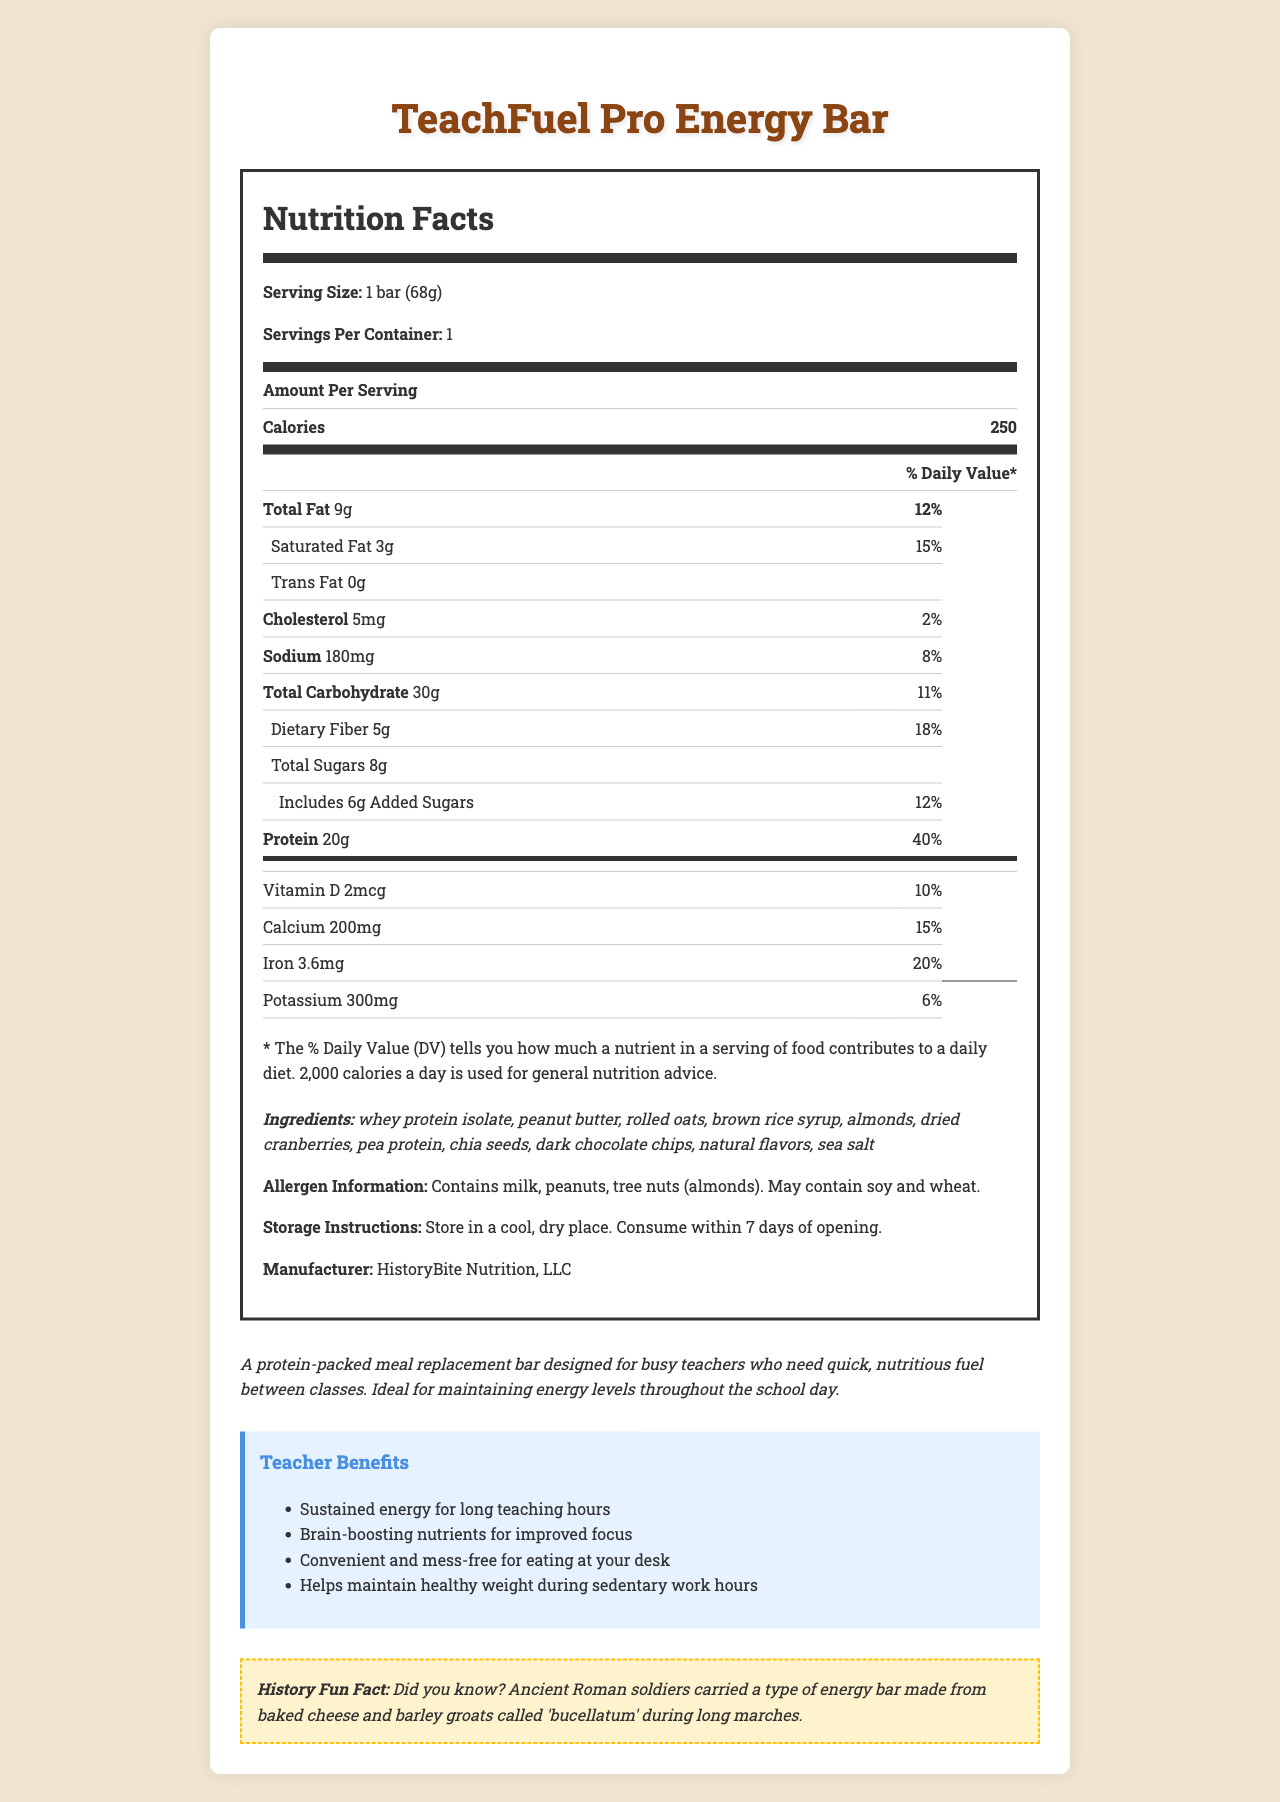what is the product name? The product name is mentioned at the beginning of the document.
Answer: TeachFuel Pro Energy Bar how many grams of protein are there per serving? The nutrition facts list 20g of protein per serving.
Answer: 20g what is the serving size of the bar? The serving size is clearly stated as 1 bar (68g).
Answer: 1 bar (68g) what percentage of daily value is the total fat? The document specifies that the total fat accounts for 12% of the daily value.
Answer: 12% which ingredient is listed first in the ingredients section? The ingredients are listed in order of predominance with whey protein isolate mentioned first.
Answer: whey protein isolate how many calories are in one serving of the TeachFuel Pro Energy Bar? The nutrition facts table lists 250 calories per serving.
Answer: 250 what allergens does this bar contain? The allergen information section states this clearly.
Answer: Contains milk, peanuts, tree nuts (almonds). May contain soy and wheat. what historical fact is mentioned about this energy bar? The fun fact section at the bottom of the document mentions this.
Answer: Did you know? Ancient Roman soldiers carried a type of energy bar made from baked cheese and barley groats called 'bucellatum' during long marches. what is the daily value percentage of dietary fiber in the bar? The document lists the dietary fiber content and its daily value percentage.
Answer: 18% which of the following does this bar contain the most of per serving? A. Protein B. Dietary Fiber C. Saturated Fat The bar contains 20g of protein, 5g dietary fiber, and 3g saturated fat.
Answer: A. Protein which benefit is not mentioned as a teacher benefit from consuming this energy bar? A. Improved Focus B. Weight Loss C. Energy for long hours D. Convenience The benefits mentioned are sustained energy, brain-boosting nutrients, convenience, and helping to maintain a healthy weight, not explicit weight loss.
Answer: B. Weight Loss is there any cholesterol in this energy bar? The document states that there is 5mg of cholesterol per serving.
Answer: Yes summarize the main idea of the document. The summary covers all key aspects mentioned in the document including the purpose, target audience, and nutritional information.
Answer: The document provides the nutrition facts, ingredients, allergen information, and benefits of the TeachFuel Pro Energy Bar, a protein-packed meal replacement designed for teachers to sustain energy and improve focus during long teaching hours. how long should you consume the bar after opening? The storage instructions clearly state the bar should be consumed within 7 days of opening.
Answer: Consume within 7 days of opening. what is the iron content per serving in terms of both amount and daily value percentage? The document lists 3.6mg of iron which is 20% of the daily value.
Answer: 3.6mg and 20% how is potassium listed in the nutrition facts? The document shows potassium content as 300mg with a daily value percentage of 6%.
Answer: Potassium 300mg, 6% who is the manufacturer of the TeachFuel Pro Energy Bar? The manufacturer is clearly listed at the end of the nutrition facts section.
Answer: HistoryBite Nutrition, LLC how many servings are there per container? The document clearly states there is one serving per container.
Answer: 1 what is the reason for including brown rice syrup as an ingredient? The document does not provide a specific reason for including brown rice syrup.
Answer: Not enough information 